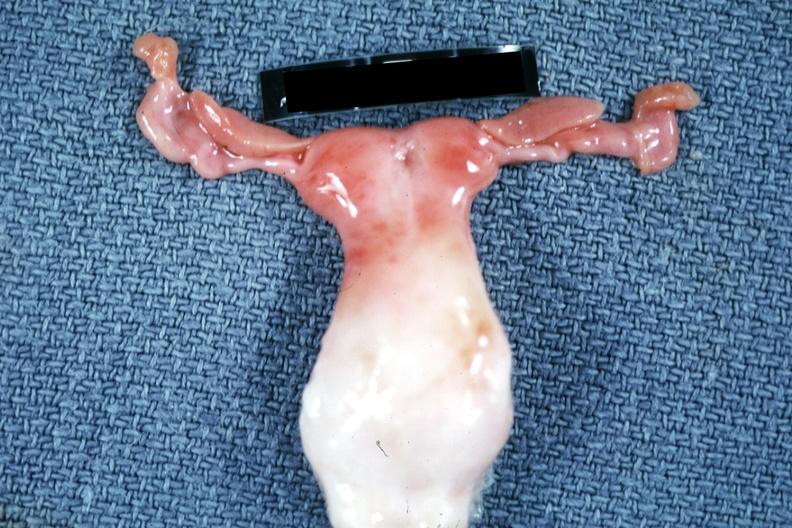where does this belong to?
Answer the question using a single word or phrase. Female reproductive system 